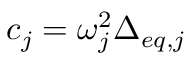<formula> <loc_0><loc_0><loc_500><loc_500>c _ { j } = \omega _ { j } ^ { 2 } \Delta _ { e q , j }</formula> 